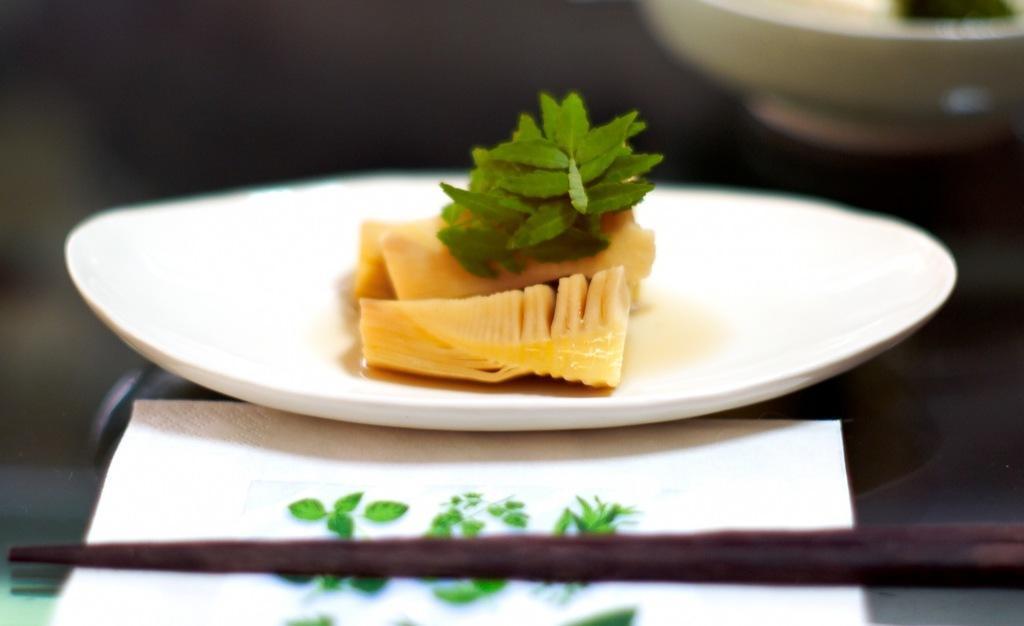Describe this image in one or two sentences. In this image we can see a bowl and a plate containing food placed on the surface. In the foreground we can see a tissue. 